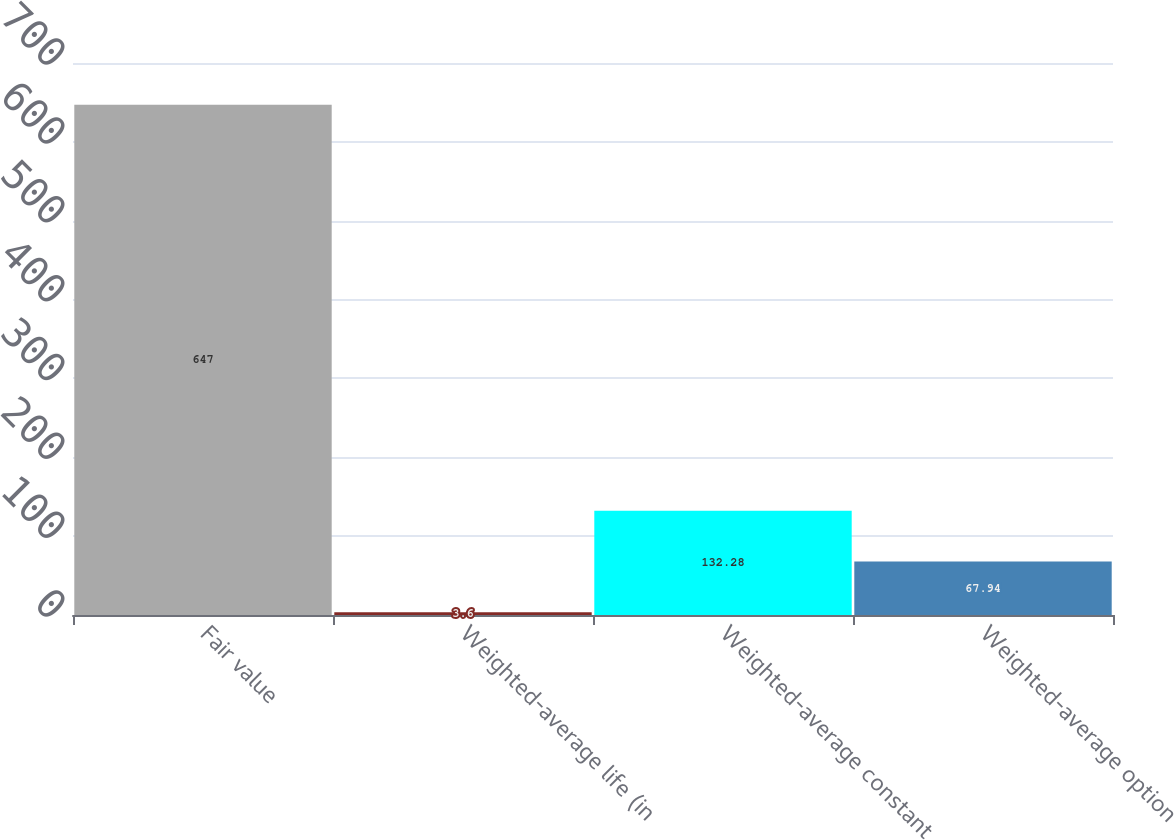Convert chart to OTSL. <chart><loc_0><loc_0><loc_500><loc_500><bar_chart><fcel>Fair value<fcel>Weighted-average life (in<fcel>Weighted-average constant<fcel>Weighted-average option<nl><fcel>647<fcel>3.6<fcel>132.28<fcel>67.94<nl></chart> 